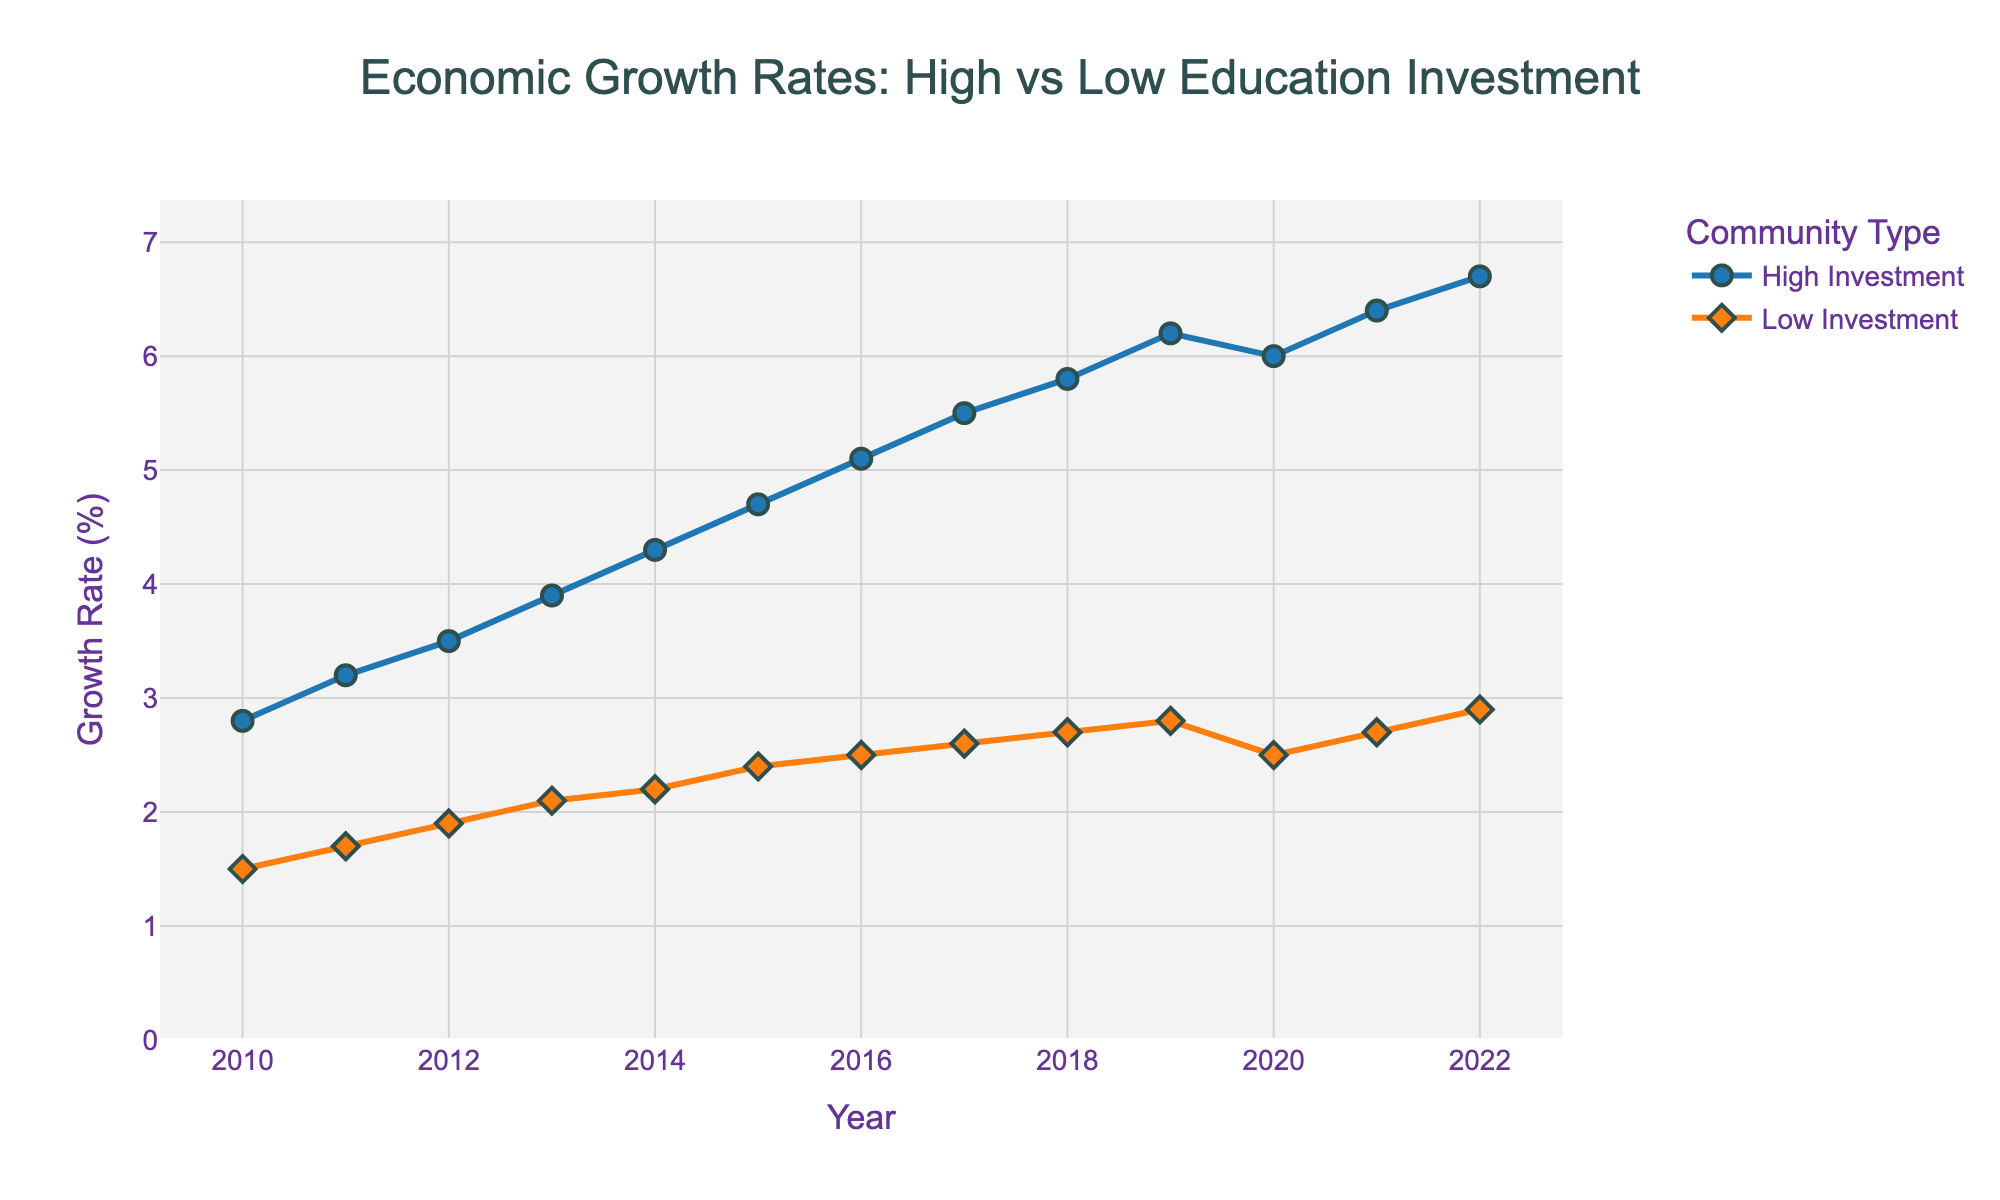Which community had a higher economic growth rate in 2012? The figure shows two lines representing the economic growth rates of communities with high and low education investments over the years. By looking at the values for 2012, the line for high investment is at 3.5%, while the line for low investment is at 1.9%.
Answer: High education investment communities What is the trend of the economic growth rate for low education investment communities from 2010 to 2022? The line for low education investment communities shows a consistent uptick from 2010 to 2022, indicating a steady increase in the economic growth rate over this period.
Answer: Steady increase What's the difference in economic growth rates between high and low education investment communities in 2019? For 2019, the growth rate for high education investment communities is 6.2%, while it is 2.8% for low education investment communities. The difference is 6.2% - 2.8% = 3.4%.
Answer: 3.4% In which year did the economic growth rate of high education investment communities decline, and by how much did it decline? The graph shows a decline in the growth rate for high education investment communities only in the year 2020, from 6.2% in 2019 to 6.0% in 2020. The decline is 6.2% - 6.0% = 0.2%.
Answer: 2020, 0.2% How much higher was the economic growth rate of high education investment communities compared to low education investment communities in 2022? In 2022, the growth rate for high education investment communities is 6.7%, while it is 2.9% for low education investment communities. The difference is 6.7% - 2.9% = 3.8%.
Answer: 3.8% What was the overall range of economic growth rates for high education investment communities from 2010 to 2022? The highest growth rate for high education investment communities was 6.7% in 2022, and the lowest was 2.8% in 2010. The range is 6.7% - 2.8% = 3.9%.
Answer: 3.9% Did the economic growth rates of low education investment communities ever exceed those of high education investment communities during the given period? By examining both lines in the figure across all the years, the low education investment communities' growth rate always remained below that of high education investment communities.
Answer: No How does the rate of growth for high education investment communities from 2010 to 2019 compare to 2019 to 2022? The growth rate for high education investment communities from 2010 (2.8%) to 2019 (6.2%) increased by 6.2% - 2.8% = 3.4%. From 2019 (6.2%) to 2022 (6.7%), it increased by 6.7% - 6.2% = 0.5%.
Answer: 3.4% vs 0.5% During which three consecutive years did high education investment communities experience the highest growth rate increase? From 2014 (4.3%) to 2017 (5.5%), the growth rate increased from 4.3% to 5.5%, a difference of 5.5% - 4.3% = 1.2% over three years.
Answer: 2014-2017 